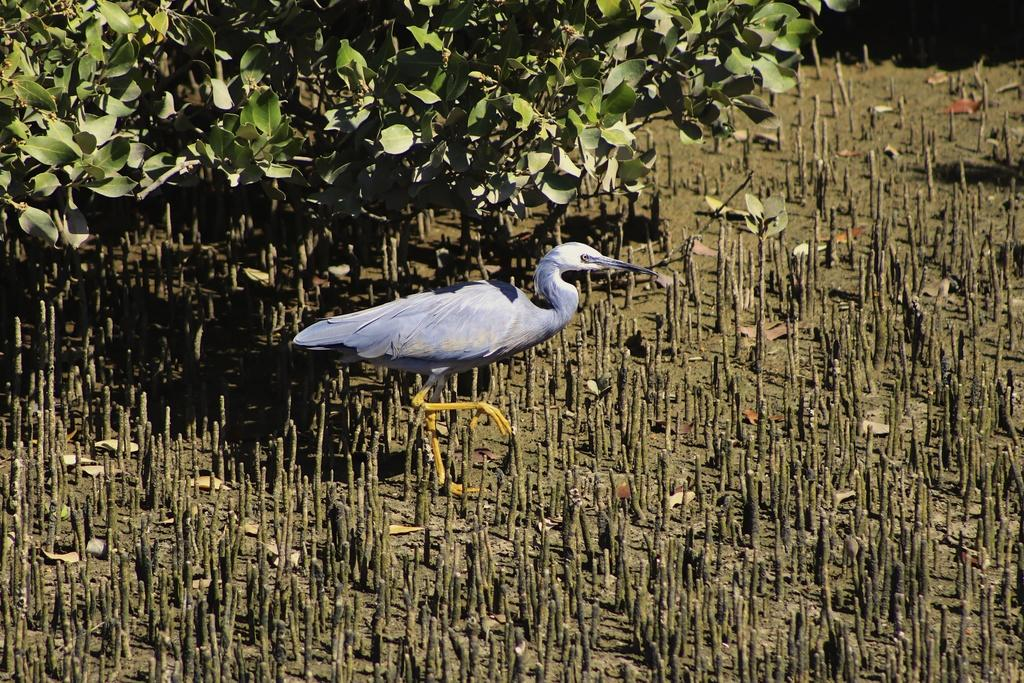What type of bird is in the image? There is a crane bird in the image. What is the crane bird doing in the image? The crane bird is walking on a surface in the image. Can you describe the surface the bird is walking on? The surface has stems. What can be seen in the background of the image? There are plants visible behind the bird. What type of pets are visible in the image? There are no pets visible in the image; it features a crane bird walking on a surface with stems. What time does the clock show in the image? There is no clock present in the image. 